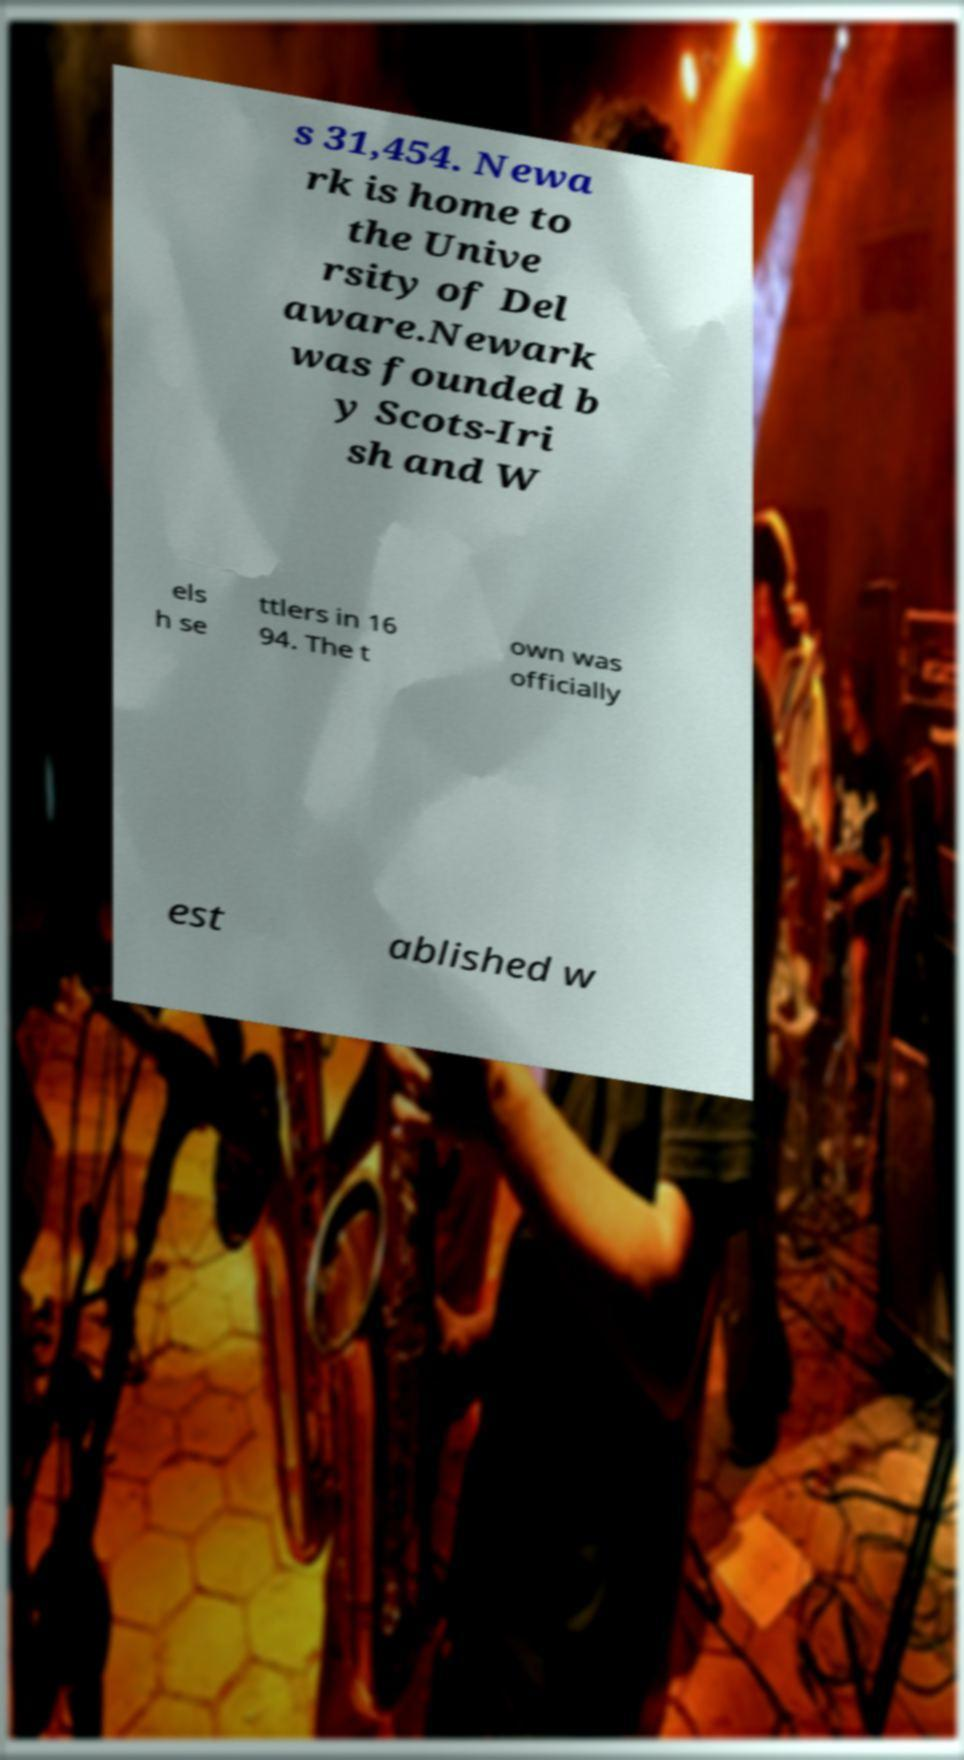What messages or text are displayed in this image? I need them in a readable, typed format. s 31,454. Newa rk is home to the Unive rsity of Del aware.Newark was founded b y Scots-Iri sh and W els h se ttlers in 16 94. The t own was officially est ablished w 